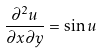<formula> <loc_0><loc_0><loc_500><loc_500>\frac { \partial ^ { 2 } u } { \partial x \partial y } = \sin { u }</formula> 